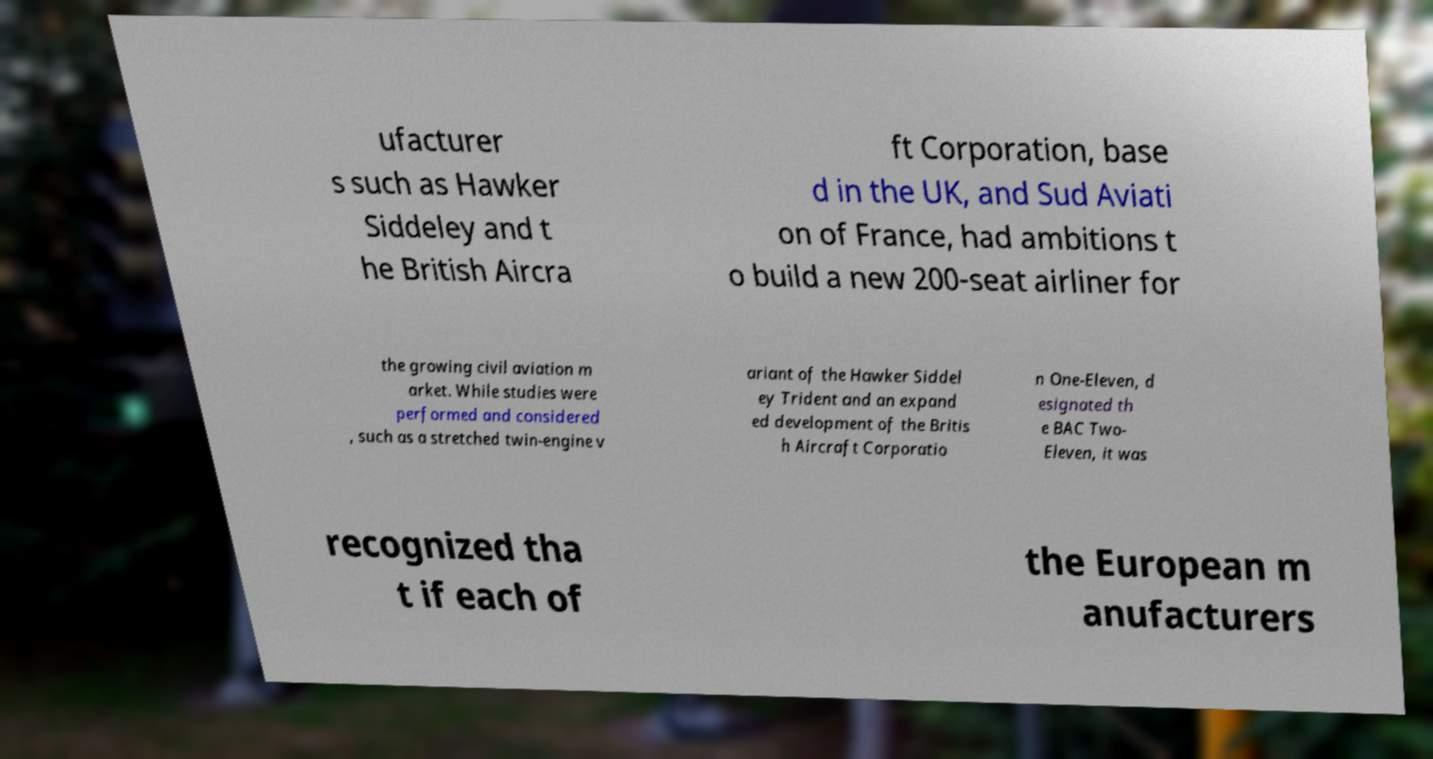I need the written content from this picture converted into text. Can you do that? ufacturer s such as Hawker Siddeley and t he British Aircra ft Corporation, base d in the UK, and Sud Aviati on of France, had ambitions t o build a new 200-seat airliner for the growing civil aviation m arket. While studies were performed and considered , such as a stretched twin-engine v ariant of the Hawker Siddel ey Trident and an expand ed development of the Britis h Aircraft Corporatio n One-Eleven, d esignated th e BAC Two- Eleven, it was recognized tha t if each of the European m anufacturers 